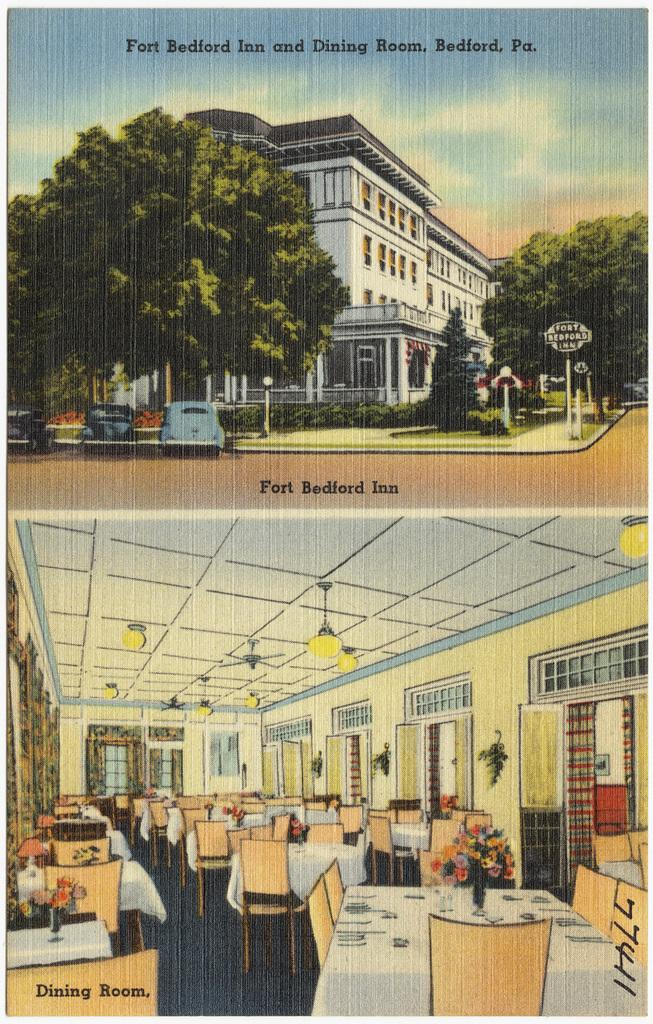<image>
Summarize the visual content of the image. A page with two pictures showing the front of Fort Bedford Inn and the Dinning room. 